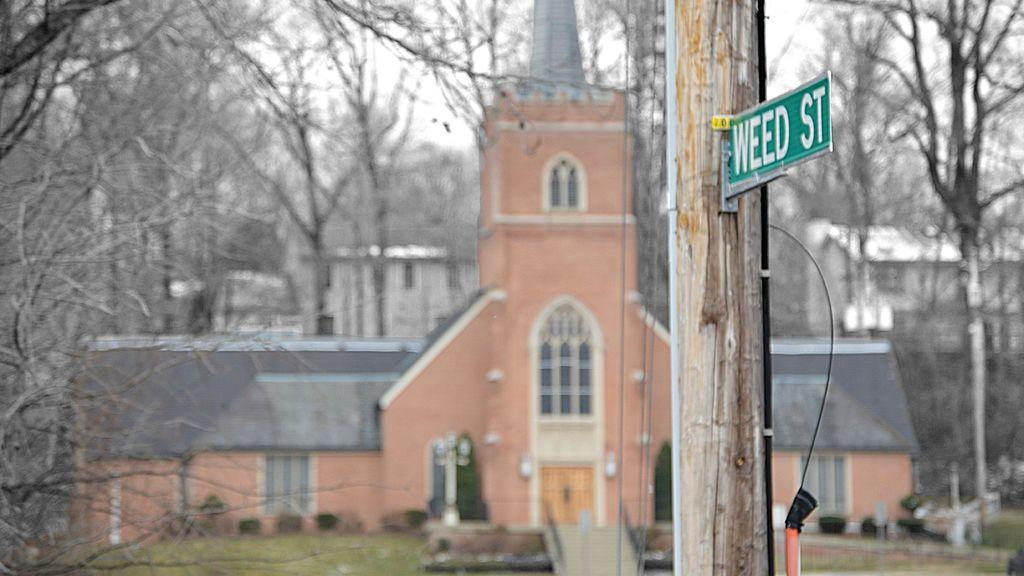What is on the pole in the image? There is a board on the pole in the image. What else can be seen on the pole? There are cables on the pole. What is visible behind the pole? Trees and buildings are visible behind the pole. What is visible at the top of the image? The sky is visible in the image. What type of dress is the pole wearing in the image? The pole is not wearing a dress, as it is an inanimate object and does not have the ability to wear clothing. 